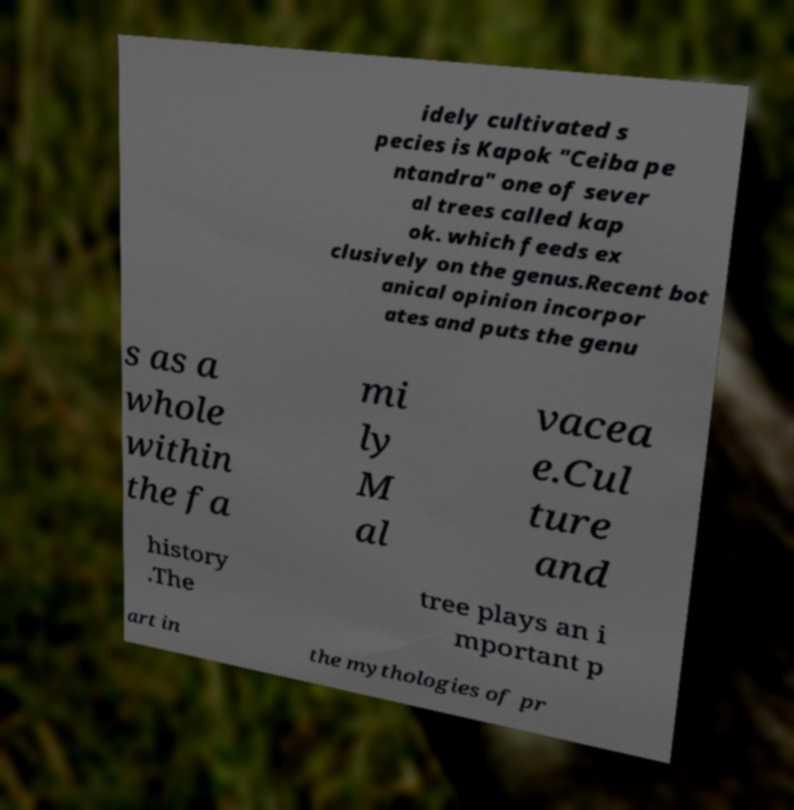Could you extract and type out the text from this image? idely cultivated s pecies is Kapok "Ceiba pe ntandra" one of sever al trees called kap ok. which feeds ex clusively on the genus.Recent bot anical opinion incorpor ates and puts the genu s as a whole within the fa mi ly M al vacea e.Cul ture and history .The tree plays an i mportant p art in the mythologies of pr 